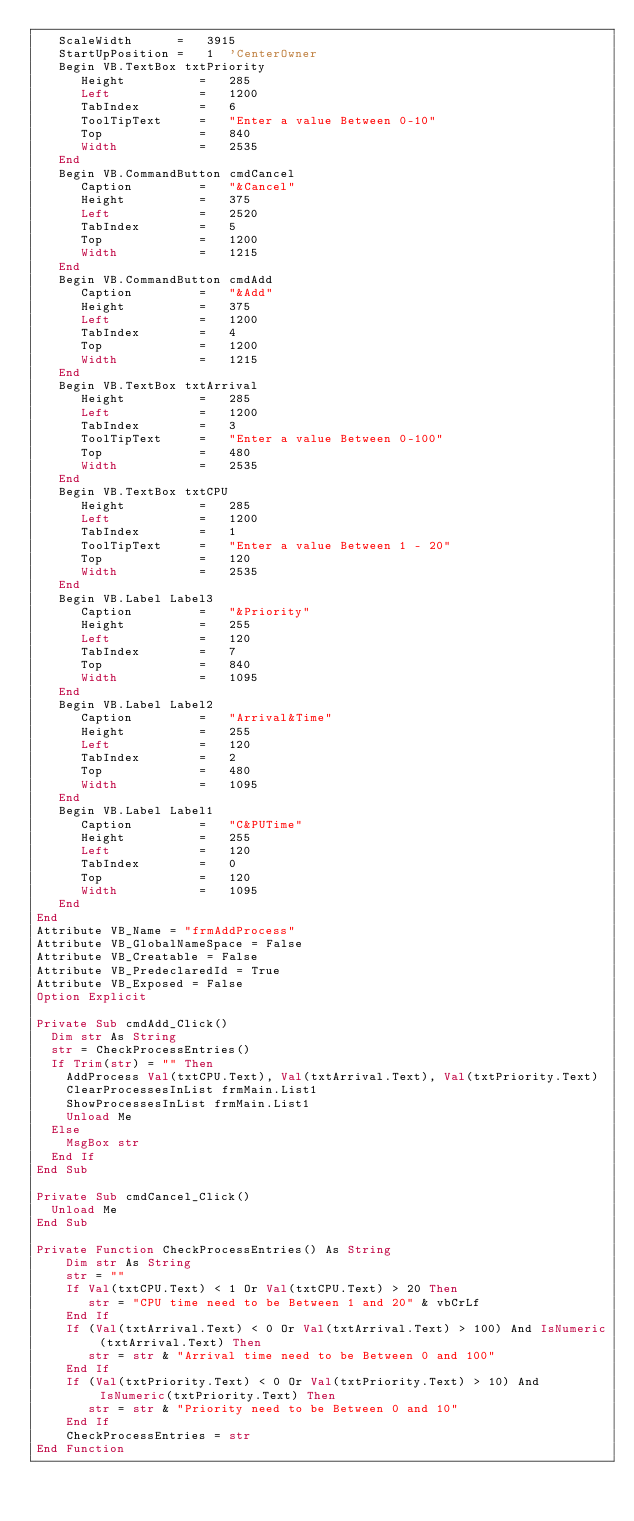<code> <loc_0><loc_0><loc_500><loc_500><_VisualBasic_>   ScaleWidth      =   3915
   StartUpPosition =   1  'CenterOwner
   Begin VB.TextBox txtPriority 
      Height          =   285
      Left            =   1200
      TabIndex        =   6
      ToolTipText     =   "Enter a value Between 0-10"
      Top             =   840
      Width           =   2535
   End
   Begin VB.CommandButton cmdCancel 
      Caption         =   "&Cancel"
      Height          =   375
      Left            =   2520
      TabIndex        =   5
      Top             =   1200
      Width           =   1215
   End
   Begin VB.CommandButton cmdAdd 
      Caption         =   "&Add"
      Height          =   375
      Left            =   1200
      TabIndex        =   4
      Top             =   1200
      Width           =   1215
   End
   Begin VB.TextBox txtArrival 
      Height          =   285
      Left            =   1200
      TabIndex        =   3
      ToolTipText     =   "Enter a value Between 0-100"
      Top             =   480
      Width           =   2535
   End
   Begin VB.TextBox txtCPU 
      Height          =   285
      Left            =   1200
      TabIndex        =   1
      ToolTipText     =   "Enter a value Between 1 - 20"
      Top             =   120
      Width           =   2535
   End
   Begin VB.Label Label3 
      Caption         =   "&Priority"
      Height          =   255
      Left            =   120
      TabIndex        =   7
      Top             =   840
      Width           =   1095
   End
   Begin VB.Label Label2 
      Caption         =   "Arrival&Time"
      Height          =   255
      Left            =   120
      TabIndex        =   2
      Top             =   480
      Width           =   1095
   End
   Begin VB.Label Label1 
      Caption         =   "C&PUTime"
      Height          =   255
      Left            =   120
      TabIndex        =   0
      Top             =   120
      Width           =   1095
   End
End
Attribute VB_Name = "frmAddProcess"
Attribute VB_GlobalNameSpace = False
Attribute VB_Creatable = False
Attribute VB_PredeclaredId = True
Attribute VB_Exposed = False
Option Explicit

Private Sub cmdAdd_Click()
  Dim str As String
  str = CheckProcessEntries()
  If Trim(str) = "" Then
    AddProcess Val(txtCPU.Text), Val(txtArrival.Text), Val(txtPriority.Text)
    ClearProcessesInList frmMain.List1
    ShowProcessesInList frmMain.List1
    Unload Me
  Else
    MsgBox str
  End If
End Sub

Private Sub cmdCancel_Click()
  Unload Me
End Sub

Private Function CheckProcessEntries() As String
    Dim str As String
    str = ""
    If Val(txtCPU.Text) < 1 Or Val(txtCPU.Text) > 20 Then
       str = "CPU time need to be Between 1 and 20" & vbCrLf
    End If
    If (Val(txtArrival.Text) < 0 Or Val(txtArrival.Text) > 100) And IsNumeric(txtArrival.Text) Then
       str = str & "Arrival time need to be Between 0 and 100"
    End If
    If (Val(txtPriority.Text) < 0 Or Val(txtPriority.Text) > 10) And IsNumeric(txtPriority.Text) Then
       str = str & "Priority need to be Between 0 and 10"
    End If
    CheckProcessEntries = str
End Function

</code> 